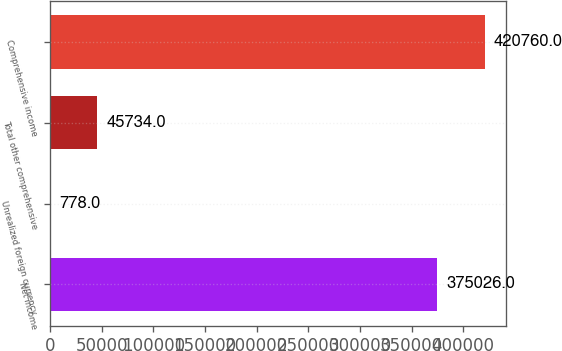Convert chart to OTSL. <chart><loc_0><loc_0><loc_500><loc_500><bar_chart><fcel>Net income<fcel>Unrealized foreign currency<fcel>Total other comprehensive<fcel>Comprehensive income<nl><fcel>375026<fcel>778<fcel>45734<fcel>420760<nl></chart> 